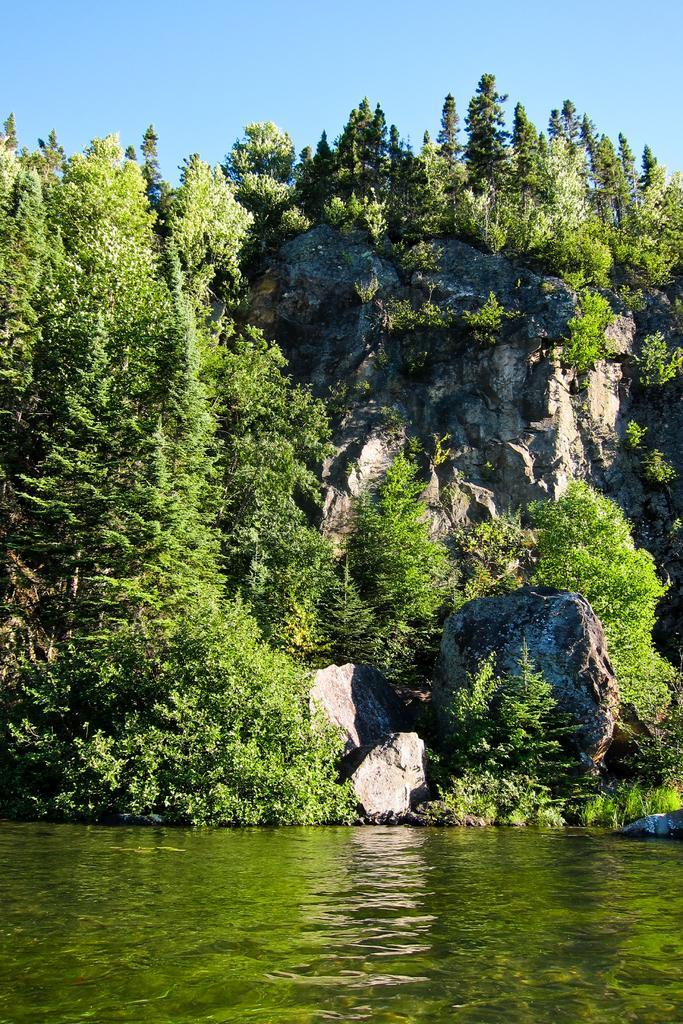Describe this image in one or two sentences. In this picture we can see the water, trees, rocks and in the background we can see the sky. 